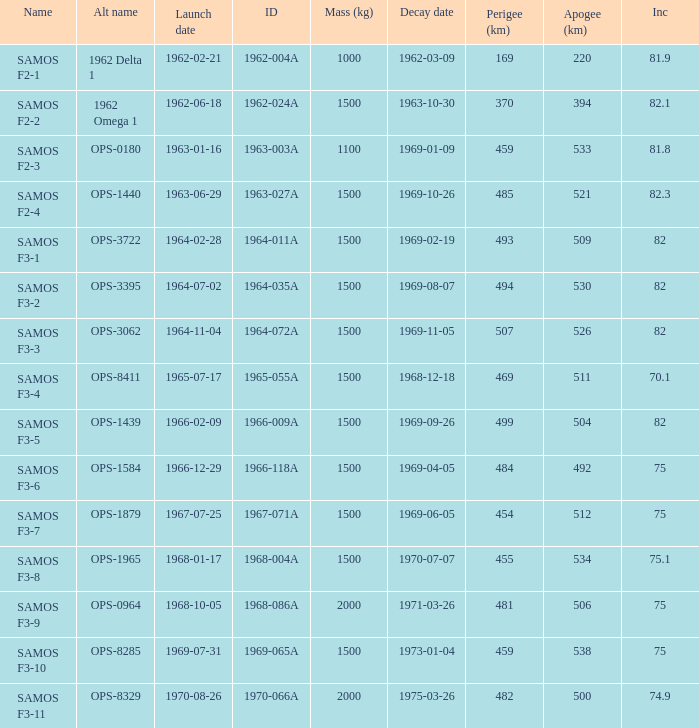What was the maximum perigee on 1969-01-09? 459.0. 